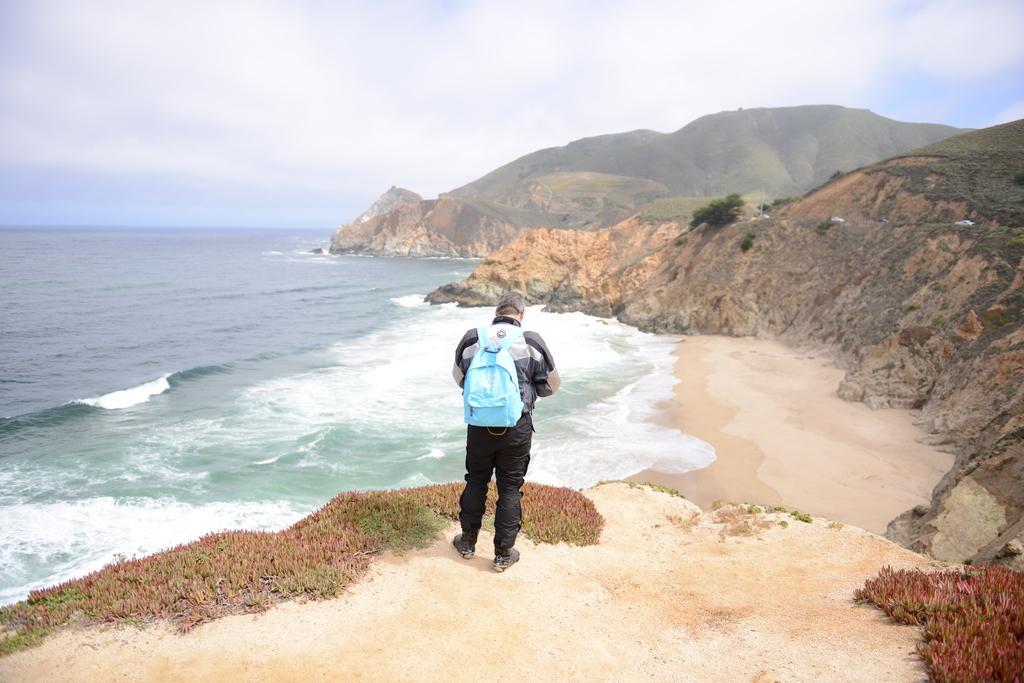Describe this image in one or two sentences. In the foreground of the picture there is a person standing, holding a backpack. In the foreground there are plants and sand. In the center of the picture there are mountains, trees and a water body. Sky is cloudy. 